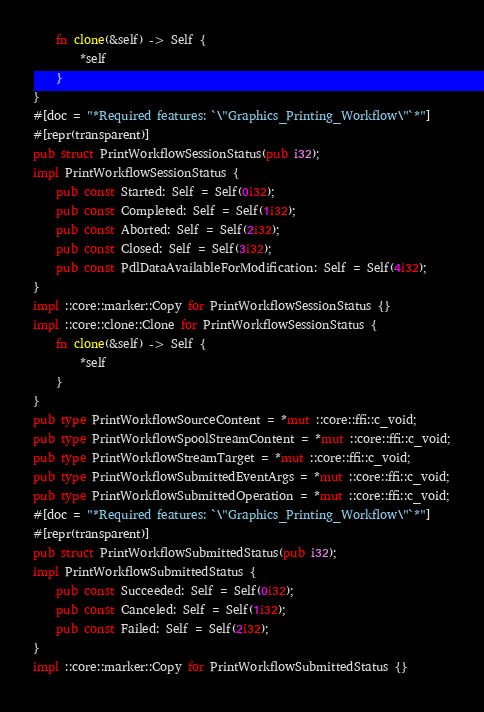<code> <loc_0><loc_0><loc_500><loc_500><_Rust_>    fn clone(&self) -> Self {
        *self
    }
}
#[doc = "*Required features: `\"Graphics_Printing_Workflow\"`*"]
#[repr(transparent)]
pub struct PrintWorkflowSessionStatus(pub i32);
impl PrintWorkflowSessionStatus {
    pub const Started: Self = Self(0i32);
    pub const Completed: Self = Self(1i32);
    pub const Aborted: Self = Self(2i32);
    pub const Closed: Self = Self(3i32);
    pub const PdlDataAvailableForModification: Self = Self(4i32);
}
impl ::core::marker::Copy for PrintWorkflowSessionStatus {}
impl ::core::clone::Clone for PrintWorkflowSessionStatus {
    fn clone(&self) -> Self {
        *self
    }
}
pub type PrintWorkflowSourceContent = *mut ::core::ffi::c_void;
pub type PrintWorkflowSpoolStreamContent = *mut ::core::ffi::c_void;
pub type PrintWorkflowStreamTarget = *mut ::core::ffi::c_void;
pub type PrintWorkflowSubmittedEventArgs = *mut ::core::ffi::c_void;
pub type PrintWorkflowSubmittedOperation = *mut ::core::ffi::c_void;
#[doc = "*Required features: `\"Graphics_Printing_Workflow\"`*"]
#[repr(transparent)]
pub struct PrintWorkflowSubmittedStatus(pub i32);
impl PrintWorkflowSubmittedStatus {
    pub const Succeeded: Self = Self(0i32);
    pub const Canceled: Self = Self(1i32);
    pub const Failed: Self = Self(2i32);
}
impl ::core::marker::Copy for PrintWorkflowSubmittedStatus {}</code> 